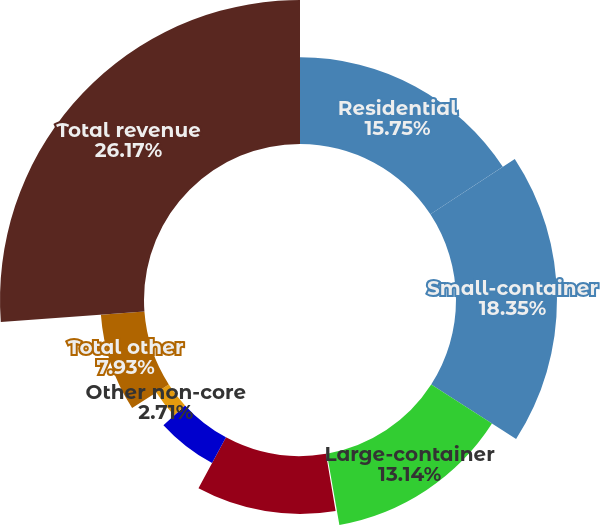<chart> <loc_0><loc_0><loc_500><loc_500><pie_chart><fcel>Residential<fcel>Small-container<fcel>Large-container<fcel>Other Total collection (1)<fcel>Landfill net<fcel>Recycling processing and<fcel>Other non-core<fcel>Total other<fcel>Total revenue<nl><fcel>15.75%<fcel>18.35%<fcel>13.14%<fcel>0.1%<fcel>10.53%<fcel>5.32%<fcel>2.71%<fcel>7.93%<fcel>26.17%<nl></chart> 